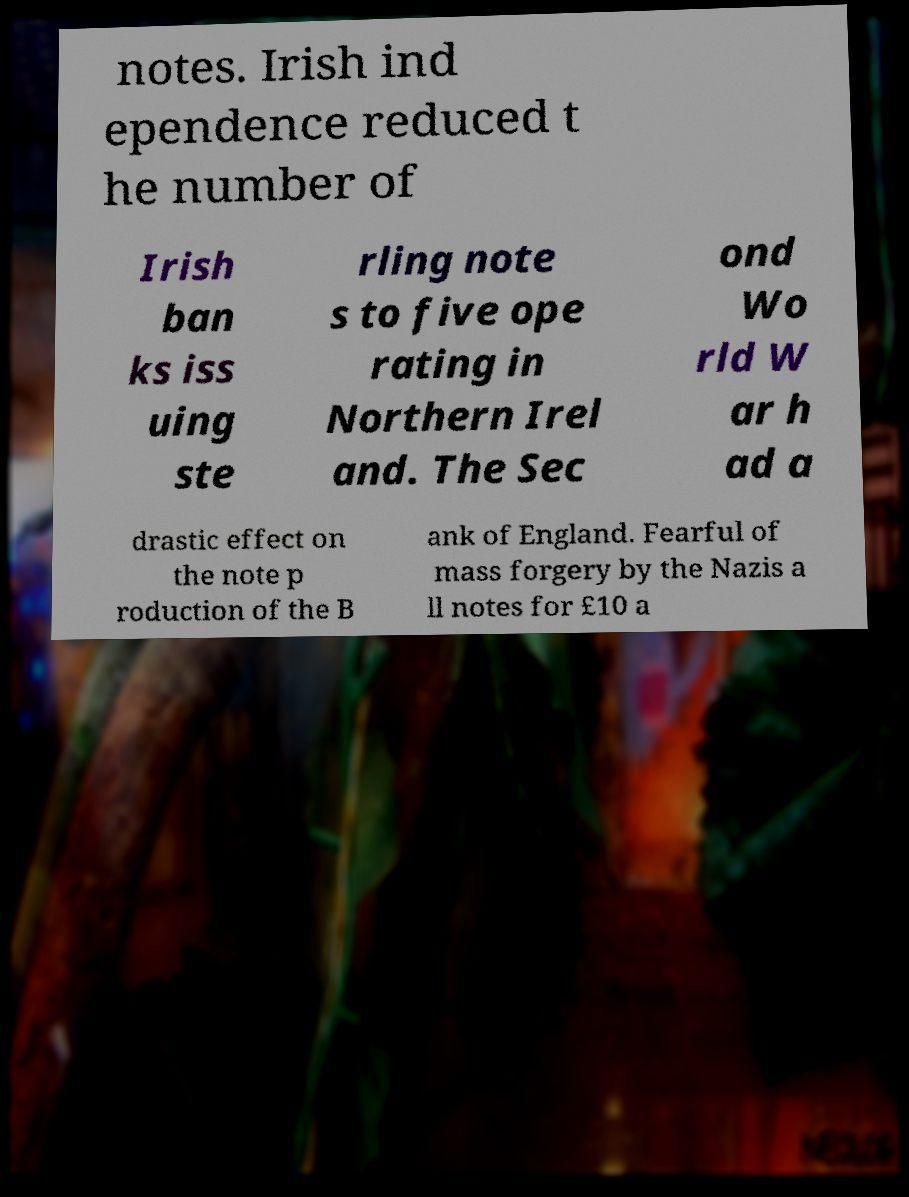For documentation purposes, I need the text within this image transcribed. Could you provide that? notes. Irish ind ependence reduced t he number of Irish ban ks iss uing ste rling note s to five ope rating in Northern Irel and. The Sec ond Wo rld W ar h ad a drastic effect on the note p roduction of the B ank of England. Fearful of mass forgery by the Nazis a ll notes for £10 a 